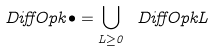Convert formula to latex. <formula><loc_0><loc_0><loc_500><loc_500>\ D i f f O p { k } { \bullet } = \bigcup _ { L \geq 0 } \ D i f f O p { k } { L }</formula> 